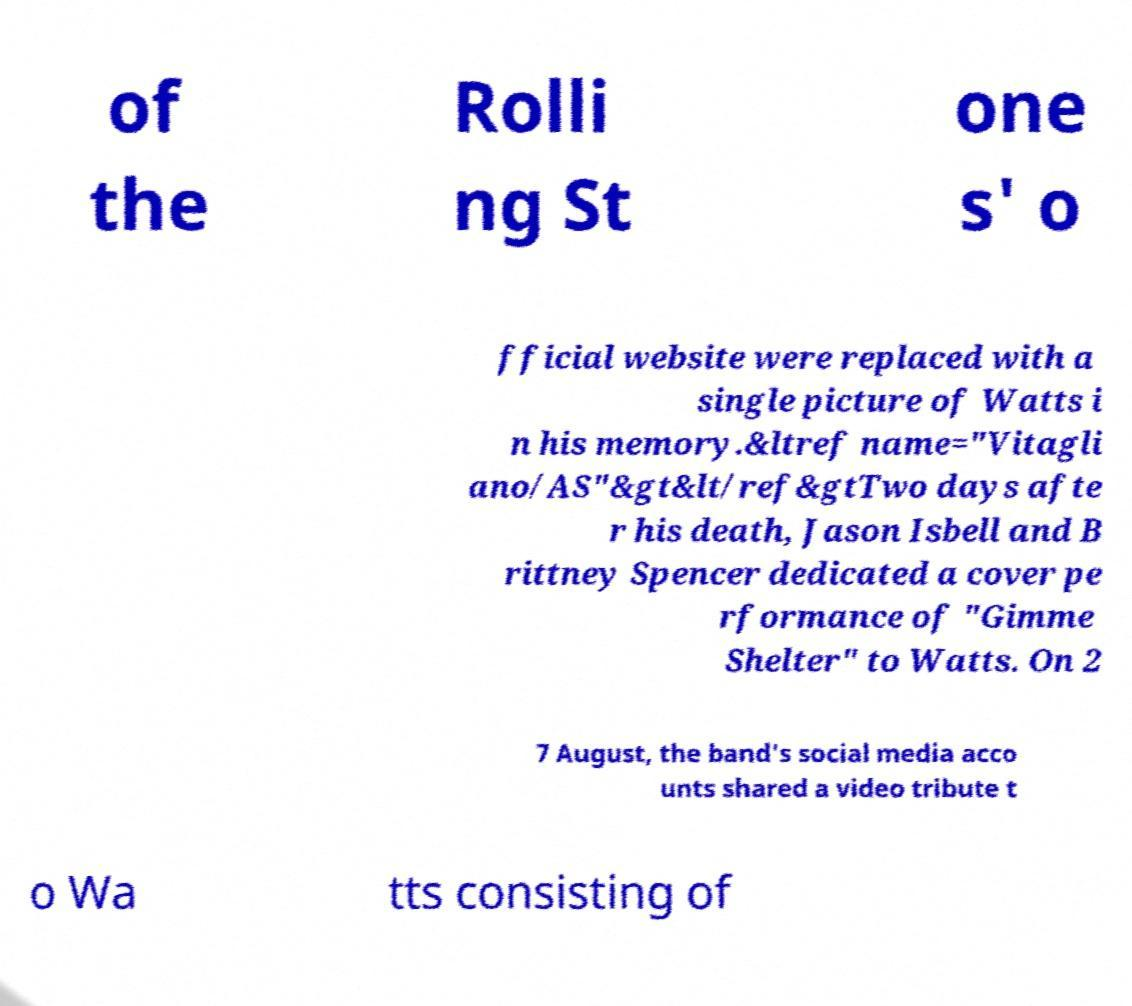Please read and relay the text visible in this image. What does it say? of the Rolli ng St one s' o fficial website were replaced with a single picture of Watts i n his memory.&ltref name="Vitagli ano/AS"&gt&lt/ref&gtTwo days afte r his death, Jason Isbell and B rittney Spencer dedicated a cover pe rformance of "Gimme Shelter" to Watts. On 2 7 August, the band's social media acco unts shared a video tribute t o Wa tts consisting of 